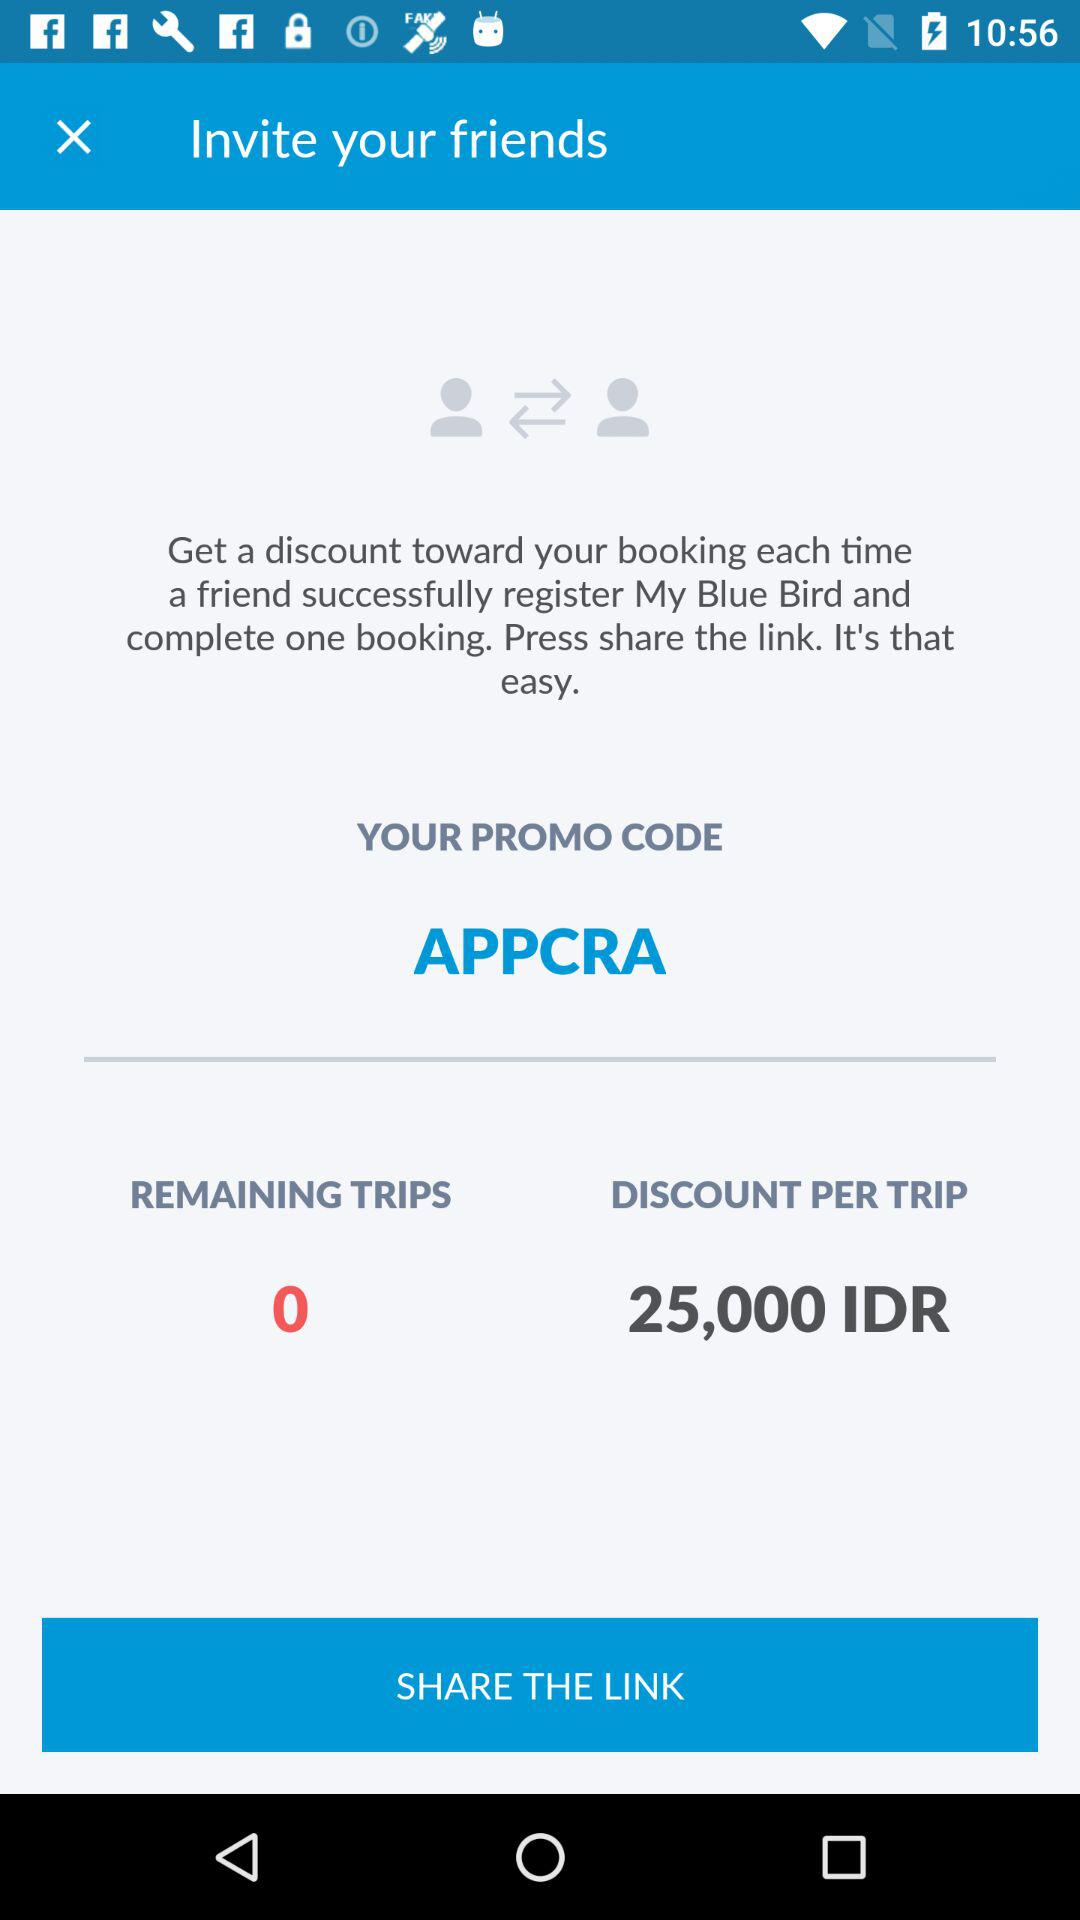What is the discount per trip? The discount per trip is 25,000 IDR. 